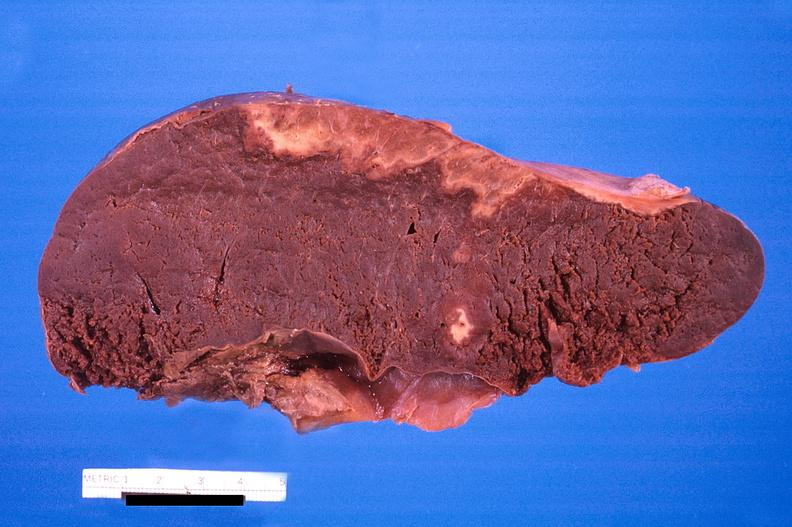s hemisection of nose present?
Answer the question using a single word or phrase. No 